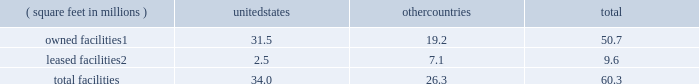There are inherent limitations on the effectiveness of our controls .
We do not expect that our disclosure controls or our internal control over financial reporting will prevent or detect all errors and all fraud .
A control system , no matter how well-designed and operated , can provide only reasonable , not absolute , assurance that the control system 2019s objectives will be met .
The design of a control system must reflect the fact that resource constraints exist , and the benefits of controls must be considered relative to their costs .
Further , because of the inherent limitations in all control systems , no evaluation of controls can provide absolute assurance that misstatements due to error or fraud will not occur or that all control issues and instances of fraud , if any , have been detected .
The design of any system of controls is based in part on certain assumptions about the likelihood of future events , and there can be no assurance that any design will succeed in achieving its stated goals under all potential future conditions .
Projections of any evaluation of the effectiveness of controls to future periods are subject to risks .
Over time , controls may become inadequate due to changes in conditions or deterioration in the degree of compliance with policies or procedures .
If our controls become inadequate , we could fail to meet our financial reporting obligations , our reputation may be adversely affected , our business and operating results could be harmed , and the market price of our stock could decline .
Item 1b .
Unresolved staff comments not applicable .
Item 2 .
Properties as of december 31 , 2016 , our major facilities consisted of : ( square feet in millions ) united states countries total owned facilities1 .
31.5 19.2 50.7 leased facilities2 .
2.5 7.1 9.6 .
1 leases and municipal grants on portions of the land used for these facilities expire on varying dates through 2109 .
2 leases expire on varying dates through 2058 and generally include renewals at our option .
Our principal executive offices are located in the u.s .
And the majority of our wafer manufacturing activities in 2016 were also located in the u.s .
One of our arizona wafer fabrication facilities is currently on hold and held in a safe state , and we are reserving the building for additional capacity and future technologies .
Incremental construction and equipment installation are required to ready the facility for its intended use .
For more information on our wafer fabrication and our assembly and test facilities , see 201cmanufacturing and assembly and test 201d in part i , item 1 of this form 10-k .
We believe that the facilities described above are suitable and adequate for our present purposes and that the productive capacity in our facilities is substantially being utilized or we have plans to utilize it .
We do not identify or allocate assets by operating segment .
For information on net property , plant and equipment by country , see 201cnote 4 : operating segments and geographic information 201d in part ii , item 8 of this form 10-k .
Item 3 .
Legal proceedings for a discussion of legal proceedings , see 201cnote 20 : commitments and contingencies 201d in part ii , item 8 of this form 10-k .
Item 4 .
Mine safety disclosures not applicable. .
What is the ratio of the owned facilities square feet in the united states to the other countries? 
Rationale: there is 1.64 square feet of owned facilities in the united states to the other countries
Computations: (31.5 / 19.2)
Answer: 1.64062. 